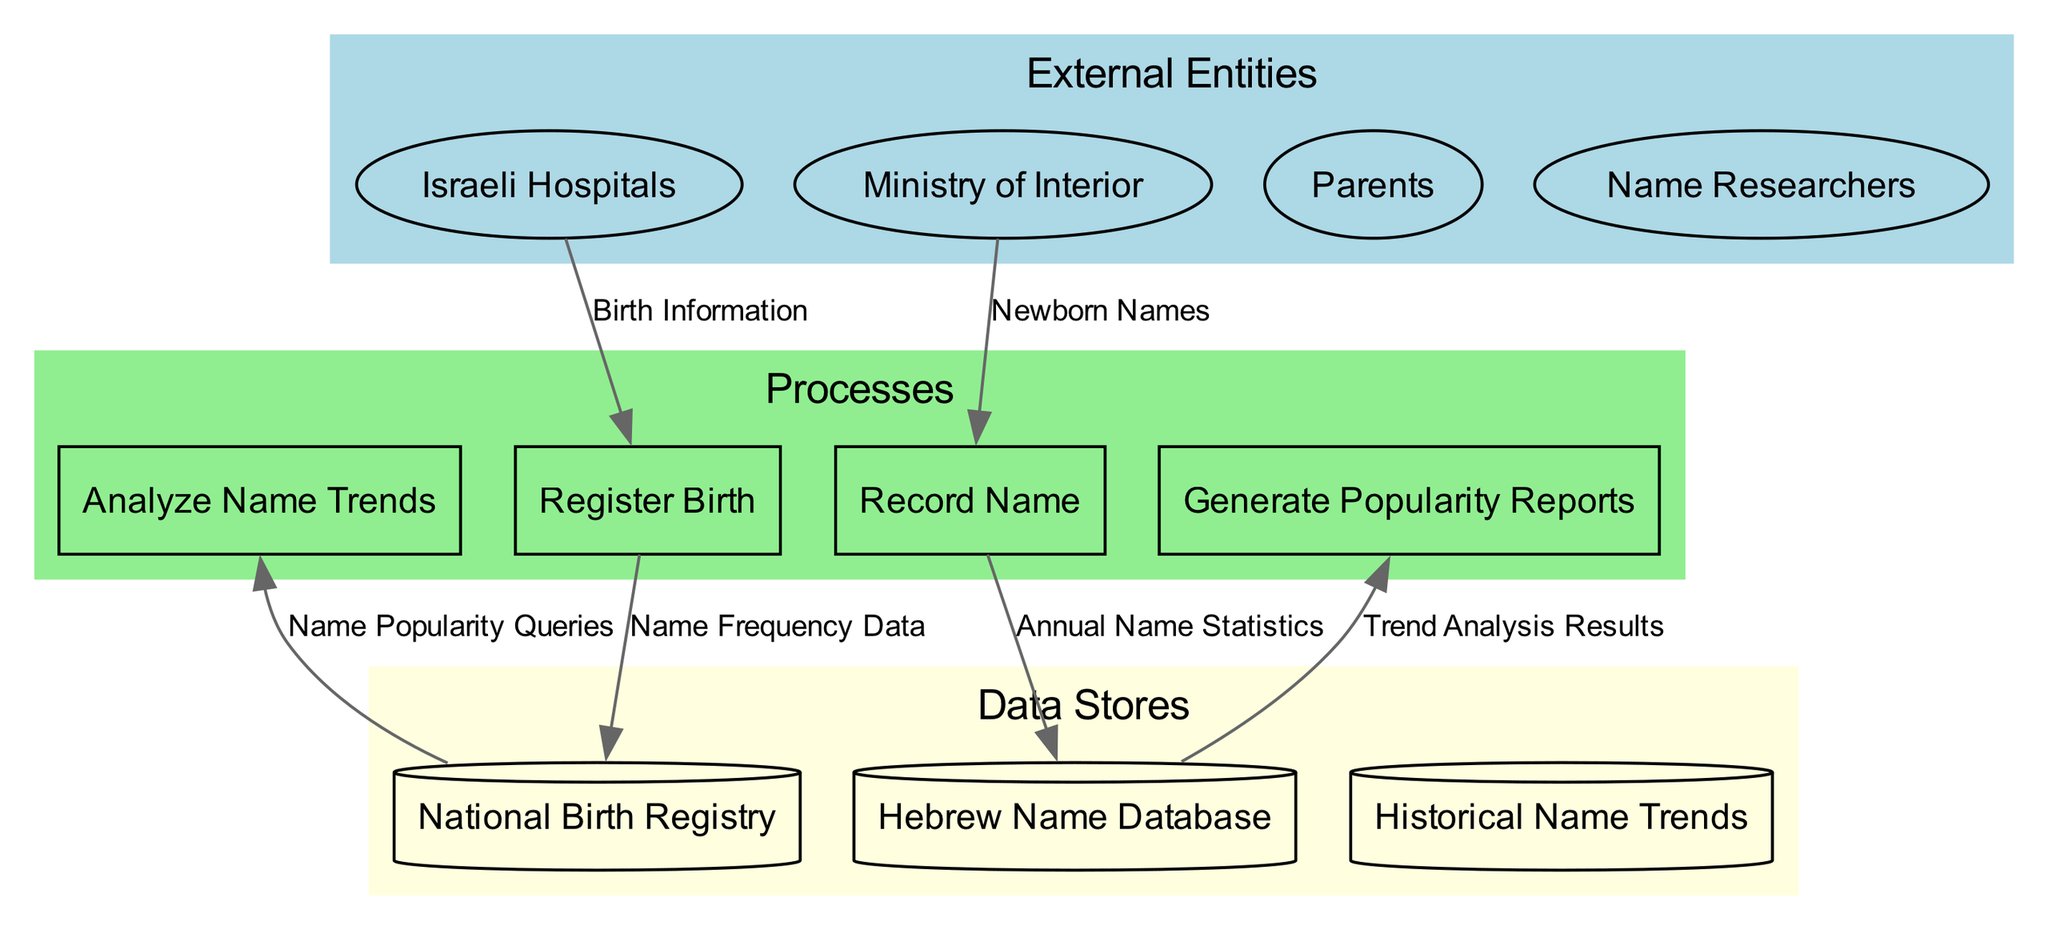What is the number of external entities in the diagram? The diagram lists four external entities: Israeli Hospitals, Ministry of Interior, Parents, and Name Researchers. Counting these entities gives us a total of four.
Answer: 4 What process is responsible for analyzing name trends? The process named "Analyze Name Trends" is specifically designated for the analysis of name trends according to the diagram.
Answer: Analyze Name Trends Which data store holds the historical name trends? The data store named "Historical Name Trends" is responsible for holding the historical trends of names as indicated in the diagram.
Answer: Historical Name Trends How many processes are included in the diagram? There are four processes depicted in the diagram: Register Birth, Record Name, Analyze Name Trends, and Generate Popularity Reports. Counting these processes results in a total of four.
Answer: 4 What data flow connects Israeli Hospitals to the processes? The data flow labeled "Birth Information" connects Israeli Hospitals to the process "Register Birth," facilitating the entry of birth details.
Answer: Birth Information What data store receives name frequency data? The "Hebrew Name Database" is the data store that receives the name frequency data as a result of the flow from the process "Record Name."
Answer: Hebrew Name Database Which external entity interacts with the "Generate Popularity Reports" process? "Name Researchers" interact with the "Generate Popularity Reports" process, as seen from the data flow connections in the diagram.
Answer: Name Researchers What is the purpose of the "Annual Name Statistics" data flow? The "Annual Name Statistics" data flow serves the purpose of providing statistical data back to the process "Analyze Name Trends" for trend analysis.
Answer: Provide statistical data Which processes output data to the data stores? The processes "Record Name" and "Analyze Name Trends" both output data to their respective data stores, namely "Hebrew Name Database" and "Historical Name Trends." This indicates their role in storing processed information.
Answer: Record Name, Analyze Name Trends 